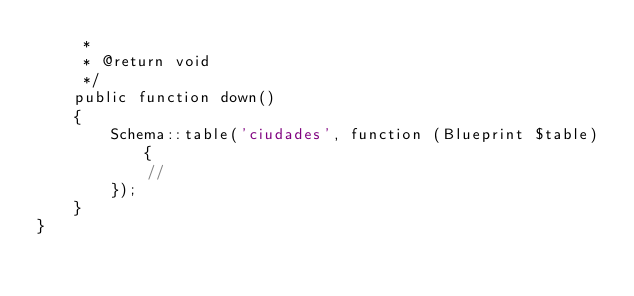Convert code to text. <code><loc_0><loc_0><loc_500><loc_500><_PHP_>     *
     * @return void
     */
    public function down()
    {
        Schema::table('ciudades', function (Blueprint $table) {
            //
        });
    }
}
</code> 